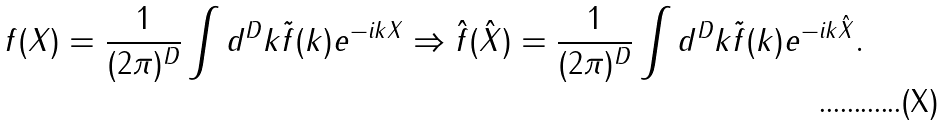<formula> <loc_0><loc_0><loc_500><loc_500>f ( X ) = \frac { 1 } { ( 2 \pi ) ^ { D } } \int d ^ { D } k \tilde { f } ( k ) e ^ { - i k X } \Rightarrow \hat { f } ( \hat { X } ) = \frac { 1 } { ( 2 \pi ) ^ { D } } \int d ^ { D } k \tilde { f } ( k ) e ^ { - i k \hat { X } } .</formula> 